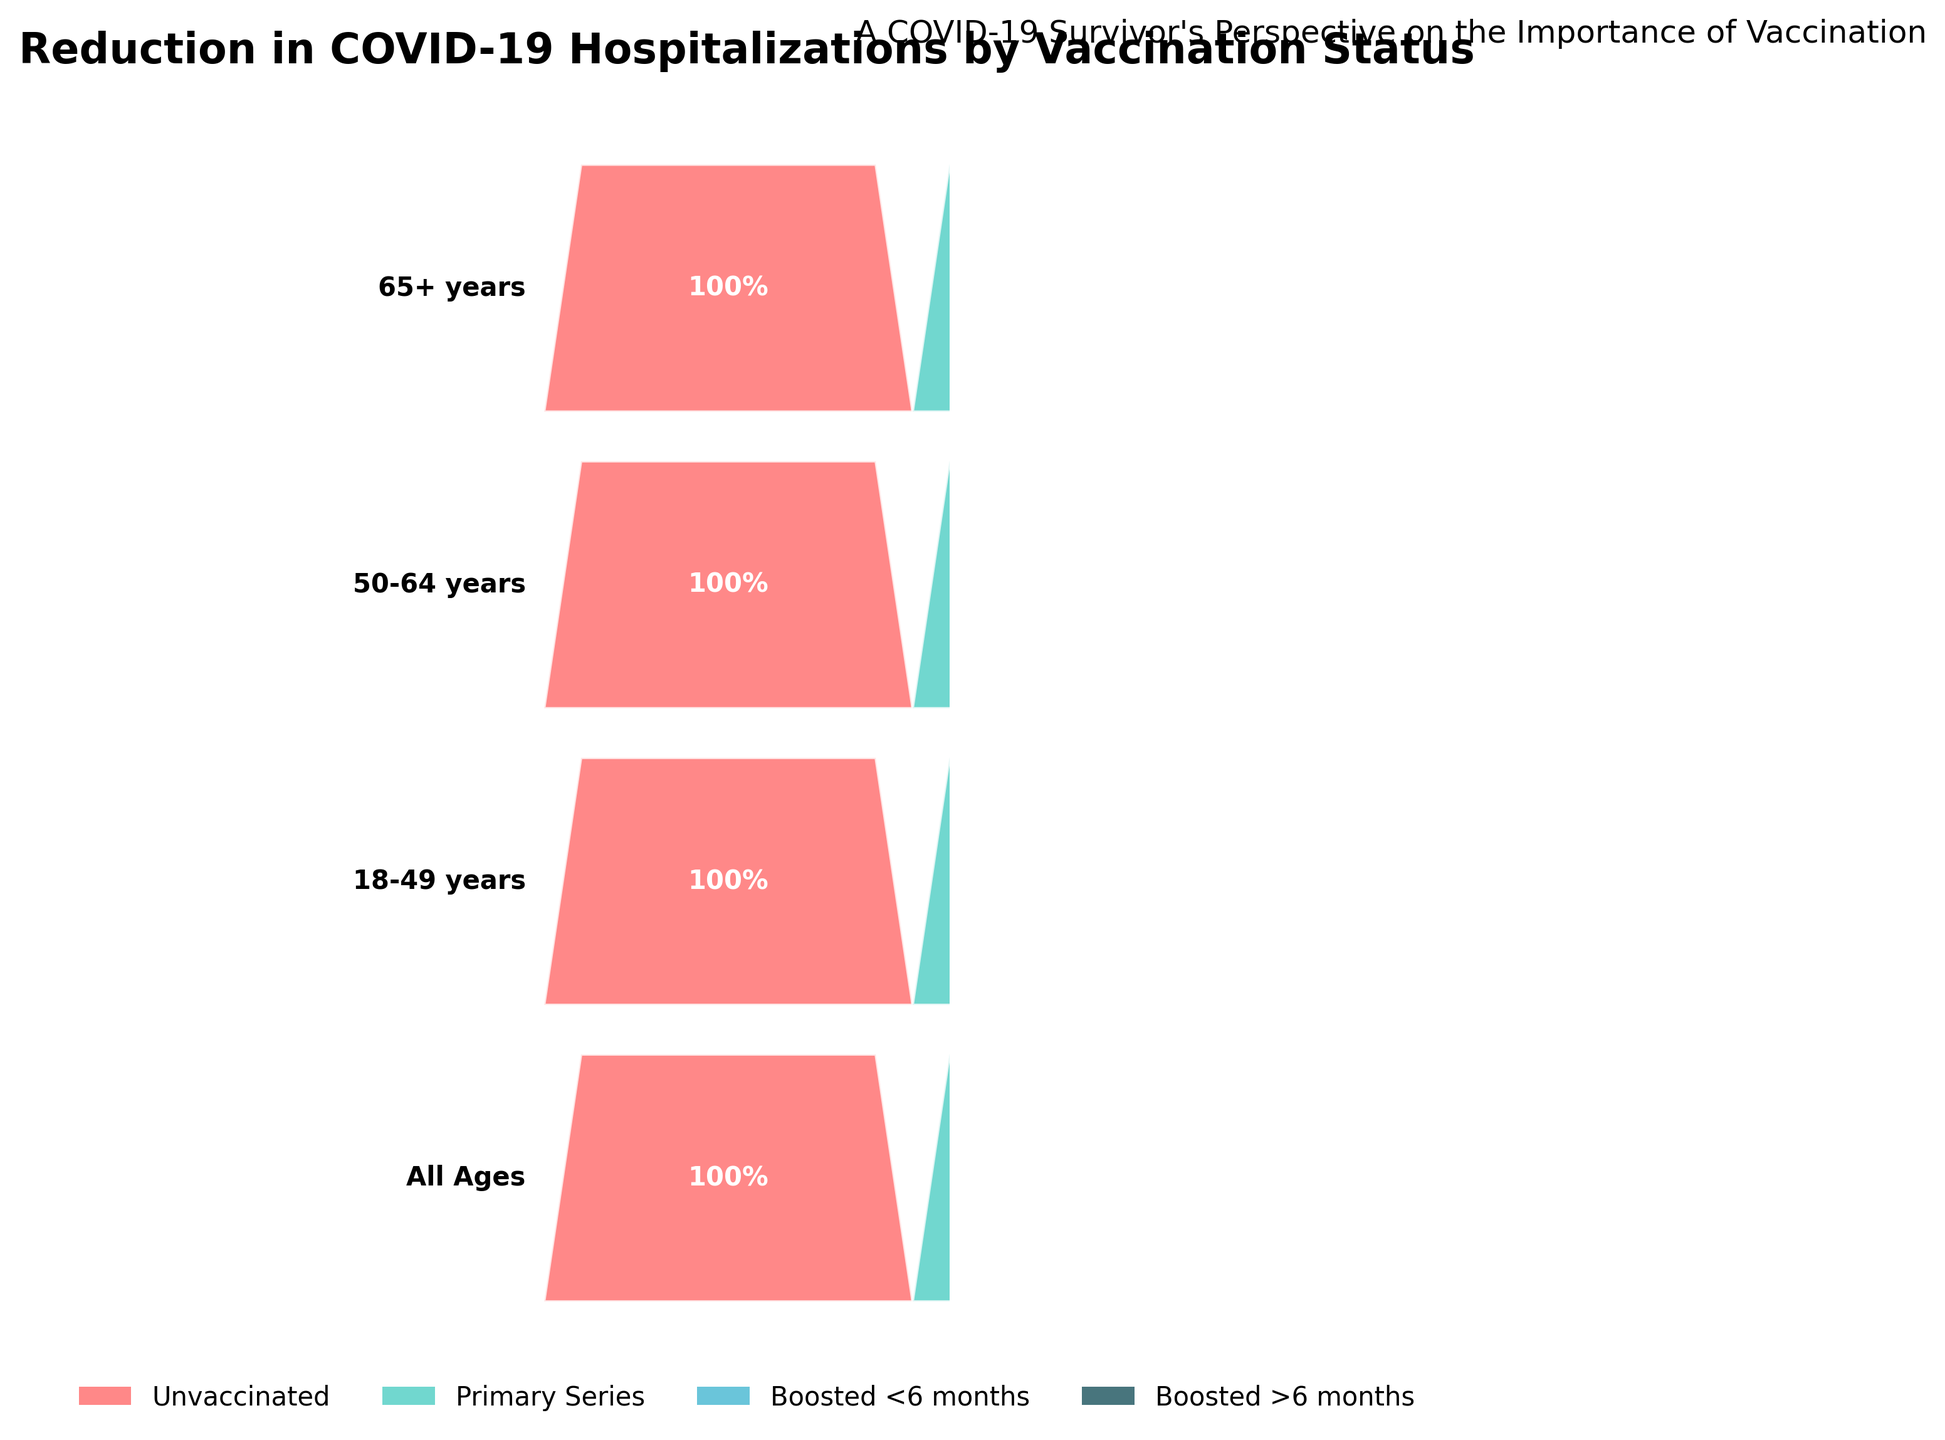What is the title of the chart? The title is usually located at the top of the chart. In this case, the title is written in bold and large font at the top.
Answer: Reduction in COVID-19 Hospitalizations by Vaccination Status Which age group shows the highest percentage reduction in hospitalizations among the 'Boosted <6 months' category? Look at the 'Boosted <6 months' category for each age group and compare the percentages. The 65+ years group has the highest value at 25%.
Answer: 65+ years How does the percentage reduction in hospitalizations compare between the 'Primary Series' and 'Boosted >6 months' for the 18-49 years category? Find the percentages for 'Primary Series' and 'Boosted >6 months' in the 18-49 years category. The percentages are 40% and 20% respectively, showing that 'Primary Series' has a higher reduction.
Answer: 'Primary Series' 40% is greater than 'Boosted >6 months' 20% What is the average percentage reduction in hospitalizations for the 'Boosted <6 months' category across all age groups? Add up the percentages for 'Boosted <6 months' across all age groups and divide by the number of age groups: (15+12+18+25)/4 = 70/4.
Answer: 17.5% In the '65+ years' category, by how much does the percentage reduction for 'Boosted >6 months' exceed that of 'Primary Series'? Find the percentages for 'Boosted >6 months' and 'Primary Series' in the 65+ years category and calculate the difference: 40% - 25% = 15%.
Answer: 15% Which category within 'All Ages' has the minimum percentage reduction in hospitalizations? Compare the percentages within 'All Ages': 100% (Unvaccinated), 45% (Primary Series), 15% (Boosted <6 months), 25% (Boosted >6 months). The lowest value is 15%.
Answer: Boosted <6 months Are there any categories where 'Unvaccinated' is not shown as 100%? Check the 'Unvaccinated' percentages for all categories; each is shown as 100%.
Answer: No, all are 100% For the 50-64 years category, what is the total percentage reduction when summing 'Primary Series' and 'Boosted >6 months'? Add the percentages for 'Primary Series' and 'Boosted >6 months' in the 50-64 years category: 50% + 30% = 80%.
Answer: 80% 